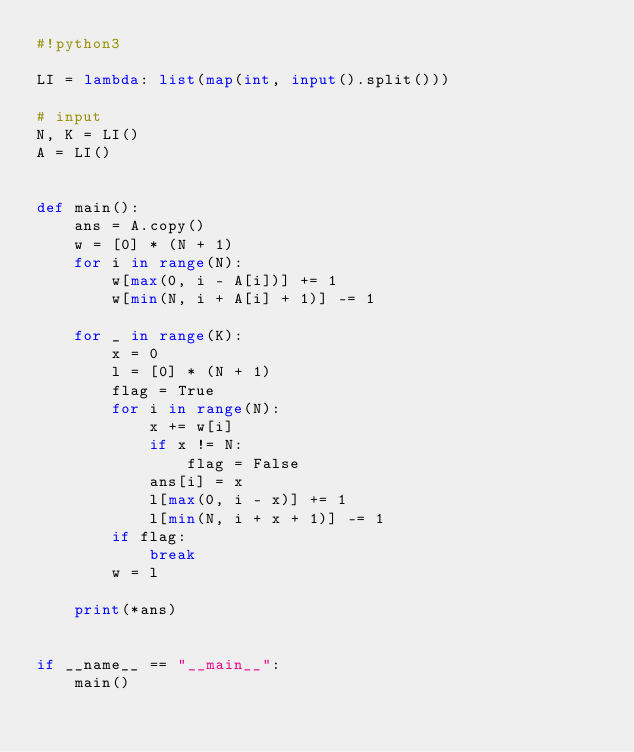<code> <loc_0><loc_0><loc_500><loc_500><_Python_>#!python3

LI = lambda: list(map(int, input().split()))

# input
N, K = LI()
A = LI()


def main():
    ans = A.copy()
    w = [0] * (N + 1)
    for i in range(N):
        w[max(0, i - A[i])] += 1
        w[min(N, i + A[i] + 1)] -= 1
    
    for _ in range(K):
        x = 0
        l = [0] * (N + 1)
        flag = True
        for i in range(N):
            x += w[i]
            if x != N:
                flag = False
            ans[i] = x
            l[max(0, i - x)] += 1
            l[min(N, i + x + 1)] -= 1
        if flag:
            break
        w = l
    
    print(*ans)


if __name__ == "__main__":
    main()
</code> 